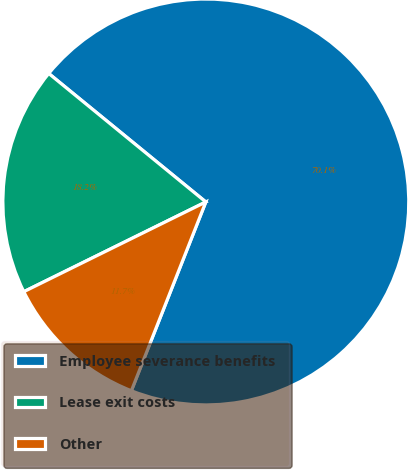<chart> <loc_0><loc_0><loc_500><loc_500><pie_chart><fcel>Employee severance benefits<fcel>Lease exit costs<fcel>Other<nl><fcel>70.06%<fcel>18.2%<fcel>11.73%<nl></chart> 